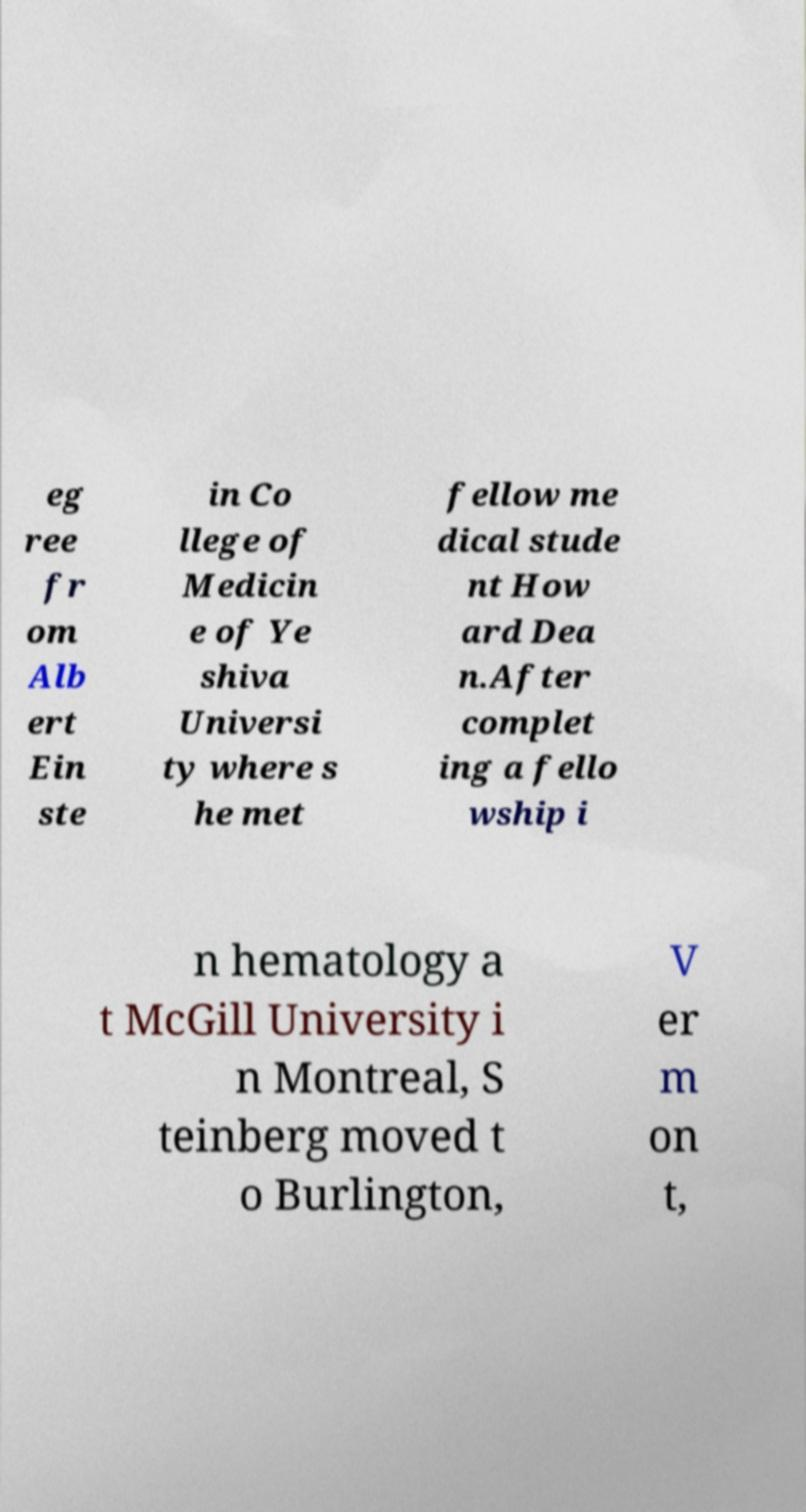For documentation purposes, I need the text within this image transcribed. Could you provide that? eg ree fr om Alb ert Ein ste in Co llege of Medicin e of Ye shiva Universi ty where s he met fellow me dical stude nt How ard Dea n.After complet ing a fello wship i n hematology a t McGill University i n Montreal, S teinberg moved t o Burlington, V er m on t, 